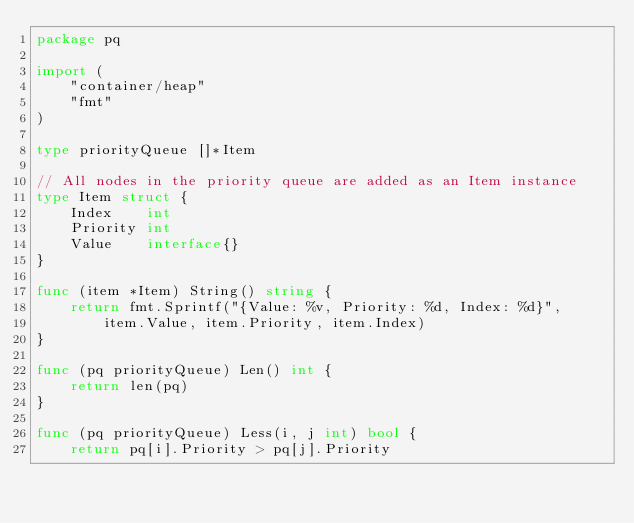<code> <loc_0><loc_0><loc_500><loc_500><_Go_>package pq

import (
	"container/heap"
	"fmt"
)

type priorityQueue []*Item

// All nodes in the priority queue are added as an Item instance
type Item struct {
	Index    int
	Priority int
	Value    interface{}
}

func (item *Item) String() string {
	return fmt.Sprintf("{Value: %v, Priority: %d, Index: %d}",
		item.Value, item.Priority, item.Index)
}

func (pq priorityQueue) Len() int {
	return len(pq)
}

func (pq priorityQueue) Less(i, j int) bool {
	return pq[i].Priority > pq[j].Priority</code> 